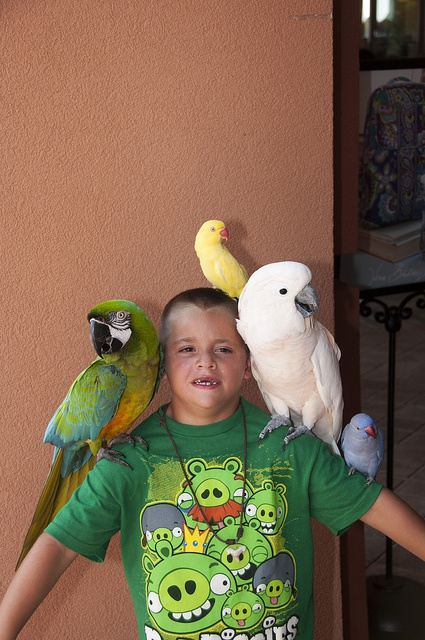Describe the objects in this image and their specific colors. I can see people in brown, darkgreen, and black tones, bird in brown, olive, black, and gray tones, bird in brown, lightgray, and darkgray tones, backpack in brown and black tones, and bird in brown, khaki, and tan tones in this image. 